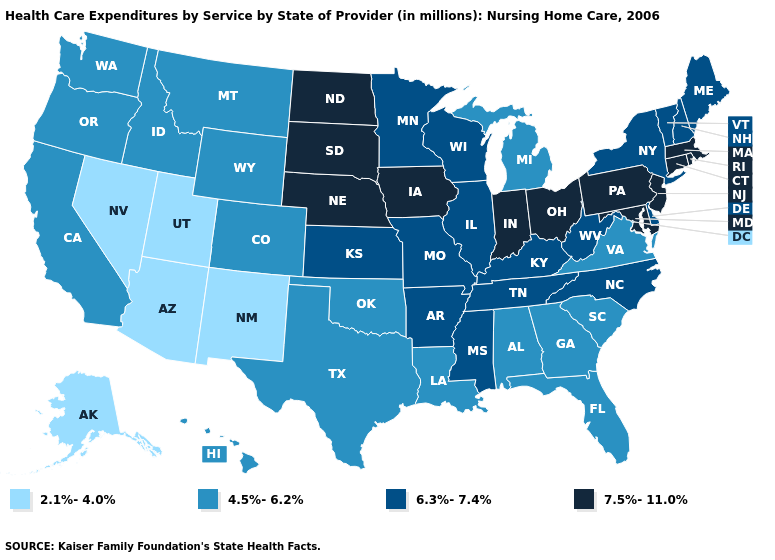Does Connecticut have the highest value in the USA?
Short answer required. Yes. What is the value of Florida?
Be succinct. 4.5%-6.2%. Name the states that have a value in the range 7.5%-11.0%?
Give a very brief answer. Connecticut, Indiana, Iowa, Maryland, Massachusetts, Nebraska, New Jersey, North Dakota, Ohio, Pennsylvania, Rhode Island, South Dakota. Name the states that have a value in the range 7.5%-11.0%?
Be succinct. Connecticut, Indiana, Iowa, Maryland, Massachusetts, Nebraska, New Jersey, North Dakota, Ohio, Pennsylvania, Rhode Island, South Dakota. Among the states that border Ohio , which have the lowest value?
Write a very short answer. Michigan. Which states have the highest value in the USA?
Quick response, please. Connecticut, Indiana, Iowa, Maryland, Massachusetts, Nebraska, New Jersey, North Dakota, Ohio, Pennsylvania, Rhode Island, South Dakota. What is the lowest value in the West?
Write a very short answer. 2.1%-4.0%. How many symbols are there in the legend?
Concise answer only. 4. Among the states that border Connecticut , does New York have the lowest value?
Write a very short answer. Yes. Among the states that border North Dakota , which have the lowest value?
Quick response, please. Montana. What is the value of Maryland?
Short answer required. 7.5%-11.0%. Name the states that have a value in the range 7.5%-11.0%?
Quick response, please. Connecticut, Indiana, Iowa, Maryland, Massachusetts, Nebraska, New Jersey, North Dakota, Ohio, Pennsylvania, Rhode Island, South Dakota. Name the states that have a value in the range 2.1%-4.0%?
Give a very brief answer. Alaska, Arizona, Nevada, New Mexico, Utah. Among the states that border Maryland , does Pennsylvania have the highest value?
Answer briefly. Yes. Name the states that have a value in the range 4.5%-6.2%?
Give a very brief answer. Alabama, California, Colorado, Florida, Georgia, Hawaii, Idaho, Louisiana, Michigan, Montana, Oklahoma, Oregon, South Carolina, Texas, Virginia, Washington, Wyoming. 